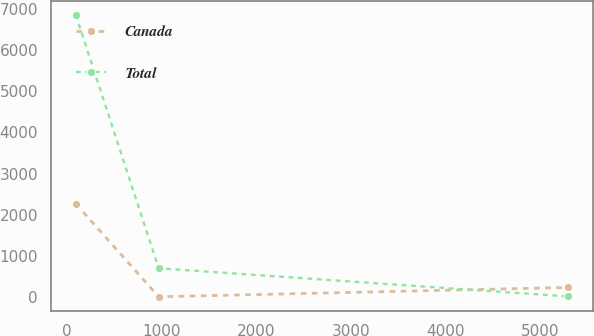<chart> <loc_0><loc_0><loc_500><loc_500><line_chart><ecel><fcel>Canada<fcel>Total<nl><fcel>91.98<fcel>2263.98<fcel>6852.56<nl><fcel>967.74<fcel>3.24<fcel>695.08<nl><fcel>5292.71<fcel>229.31<fcel>10.91<nl></chart> 